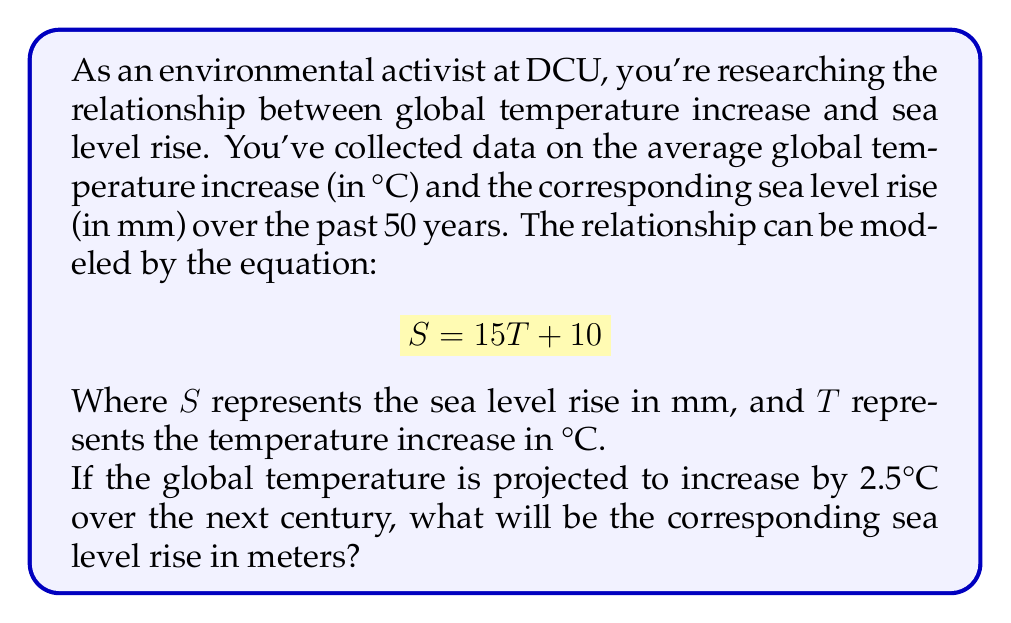Help me with this question. To solve this problem, we'll follow these steps:

1. Understand the given equation:
   $$ S = 15T + 10 $$
   Where $S$ is sea level rise in mm, and $T$ is temperature increase in °C.

2. Substitute the projected temperature increase:
   $T = 2.5°C$

3. Calculate the sea level rise in mm:
   $$ S = 15(2.5) + 10 $$
   $$ S = 37.5 + 10 $$
   $$ S = 47.5 \text{ mm} $$

4. Convert the result from mm to meters:
   $$ 47.5 \text{ mm} = 47.5 \div 1000 = 0.0475 \text{ m} $$

Therefore, a temperature increase of 2.5°C is projected to cause a sea level rise of 0.0475 meters.
Answer: 0.0475 meters 